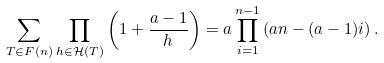<formula> <loc_0><loc_0><loc_500><loc_500>\sum _ { T \in F ( n ) } \prod _ { h \in \mathcal { H } ( T ) } \left ( 1 + \frac { a - 1 } { h } \right ) = a \prod _ { i = 1 } ^ { n - 1 } \left ( a n - ( a - 1 ) i \right ) .</formula> 